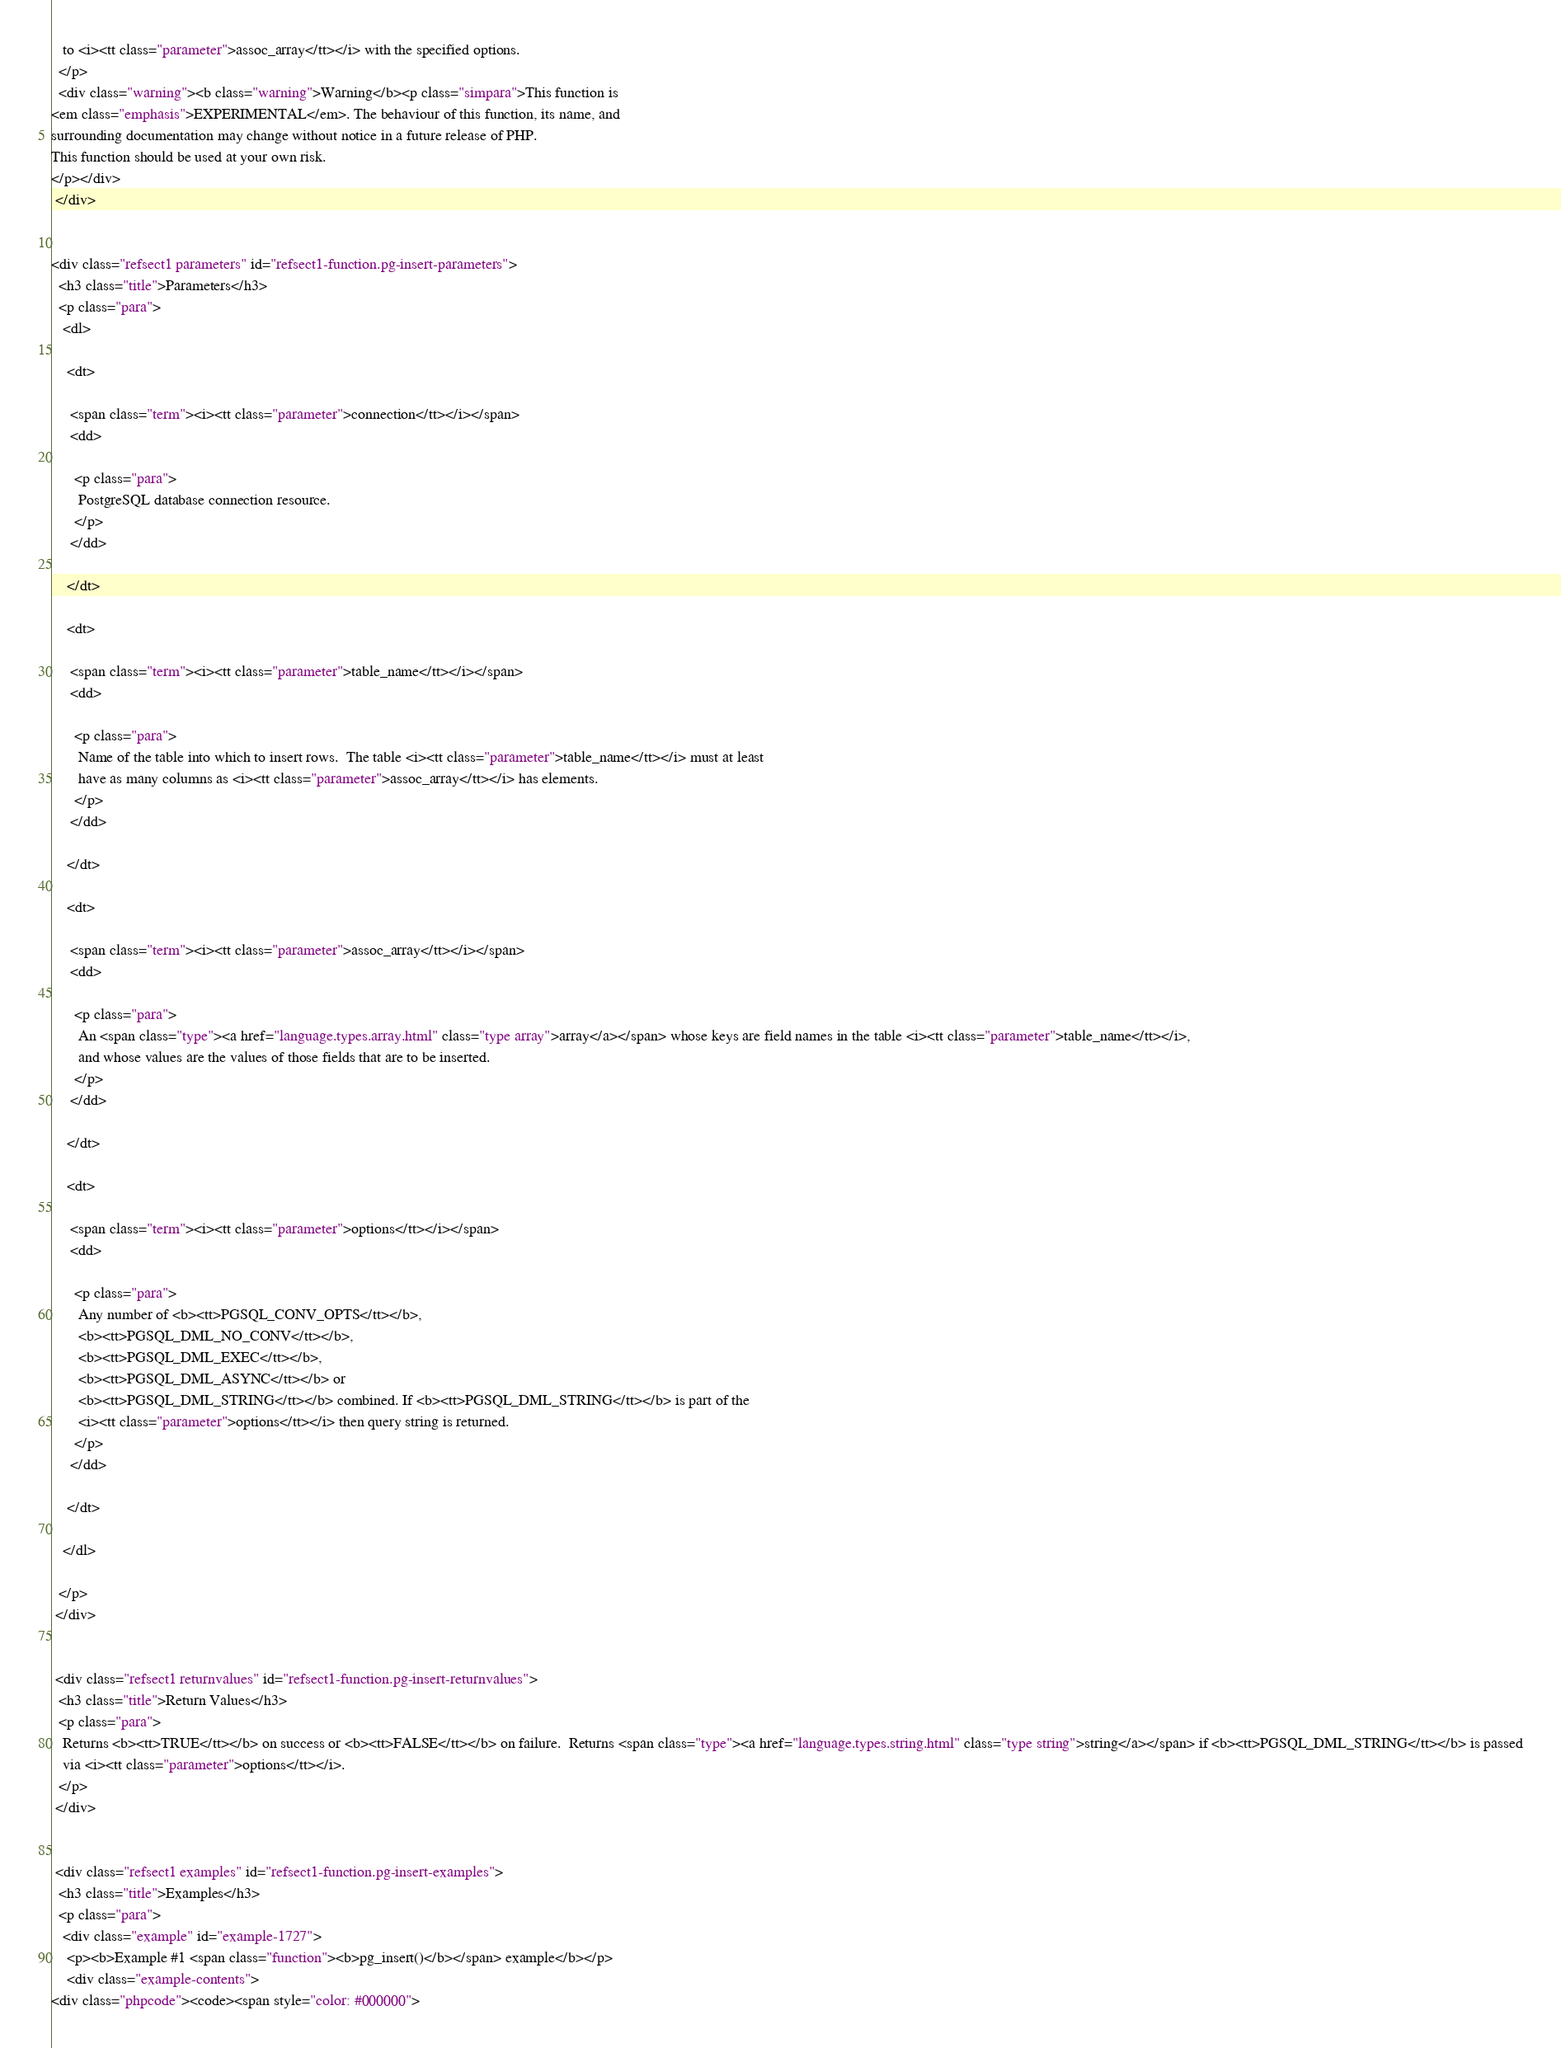<code> <loc_0><loc_0><loc_500><loc_500><_HTML_>   to <i><tt class="parameter">assoc_array</tt></i> with the specified options.
  </p>
  <div class="warning"><b class="warning">Warning</b><p class="simpara">This function is
<em class="emphasis">EXPERIMENTAL</em>. The behaviour of this function, its name, and
surrounding documentation may change without notice in a future release of PHP.
This function should be used at your own risk.
</p></div>
 </div>


<div class="refsect1 parameters" id="refsect1-function.pg-insert-parameters">
  <h3 class="title">Parameters</h3>
  <p class="para">
   <dl>

    <dt>

     <span class="term"><i><tt class="parameter">connection</tt></i></span>
     <dd>

      <p class="para">
       PostgreSQL database connection resource.
      </p>
     </dd>

    </dt>

    <dt>

     <span class="term"><i><tt class="parameter">table_name</tt></i></span>
     <dd>

      <p class="para">
       Name of the table into which to insert rows.  The table <i><tt class="parameter">table_name</tt></i> must at least 
       have as many columns as <i><tt class="parameter">assoc_array</tt></i> has elements.
      </p>
     </dd>

    </dt>

    <dt>

     <span class="term"><i><tt class="parameter">assoc_array</tt></i></span>
     <dd>

      <p class="para">
       An <span class="type"><a href="language.types.array.html" class="type array">array</a></span> whose keys are field names in the table <i><tt class="parameter">table_name</tt></i>,
       and whose values are the values of those fields that are to be inserted.
      </p>
     </dd>

    </dt>

    <dt>

     <span class="term"><i><tt class="parameter">options</tt></i></span>
     <dd>

      <p class="para">
       Any number of <b><tt>PGSQL_CONV_OPTS</tt></b>, 
       <b><tt>PGSQL_DML_NO_CONV</tt></b>,
       <b><tt>PGSQL_DML_EXEC</tt></b>,
       <b><tt>PGSQL_DML_ASYNC</tt></b> or
       <b><tt>PGSQL_DML_STRING</tt></b> combined. If <b><tt>PGSQL_DML_STRING</tt></b> is part of the
       <i><tt class="parameter">options</tt></i> then query string is returned.
      </p>
     </dd>

    </dt>

   </dl>

  </p>
 </div>


 <div class="refsect1 returnvalues" id="refsect1-function.pg-insert-returnvalues">
  <h3 class="title">Return Values</h3>
  <p class="para">
   Returns <b><tt>TRUE</tt></b> on success or <b><tt>FALSE</tt></b> on failure.  Returns <span class="type"><a href="language.types.string.html" class="type string">string</a></span> if <b><tt>PGSQL_DML_STRING</tt></b> is passed
   via <i><tt class="parameter">options</tt></i>.
  </p>
 </div>

 
 <div class="refsect1 examples" id="refsect1-function.pg-insert-examples">
  <h3 class="title">Examples</h3>
  <p class="para">
   <div class="example" id="example-1727">
    <p><b>Example #1 <span class="function"><b>pg_insert()</b></span> example</b></p>
    <div class="example-contents">
<div class="phpcode"><code><span style="color: #000000"></code> 